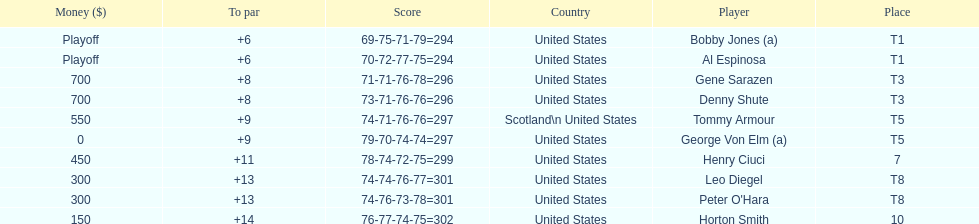Which two players tied for first place? Bobby Jones (a), Al Espinosa. 